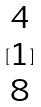Convert formula to latex. <formula><loc_0><loc_0><loc_500><loc_500>[ \begin{matrix} 4 \\ 1 \\ 8 \end{matrix} ]</formula> 